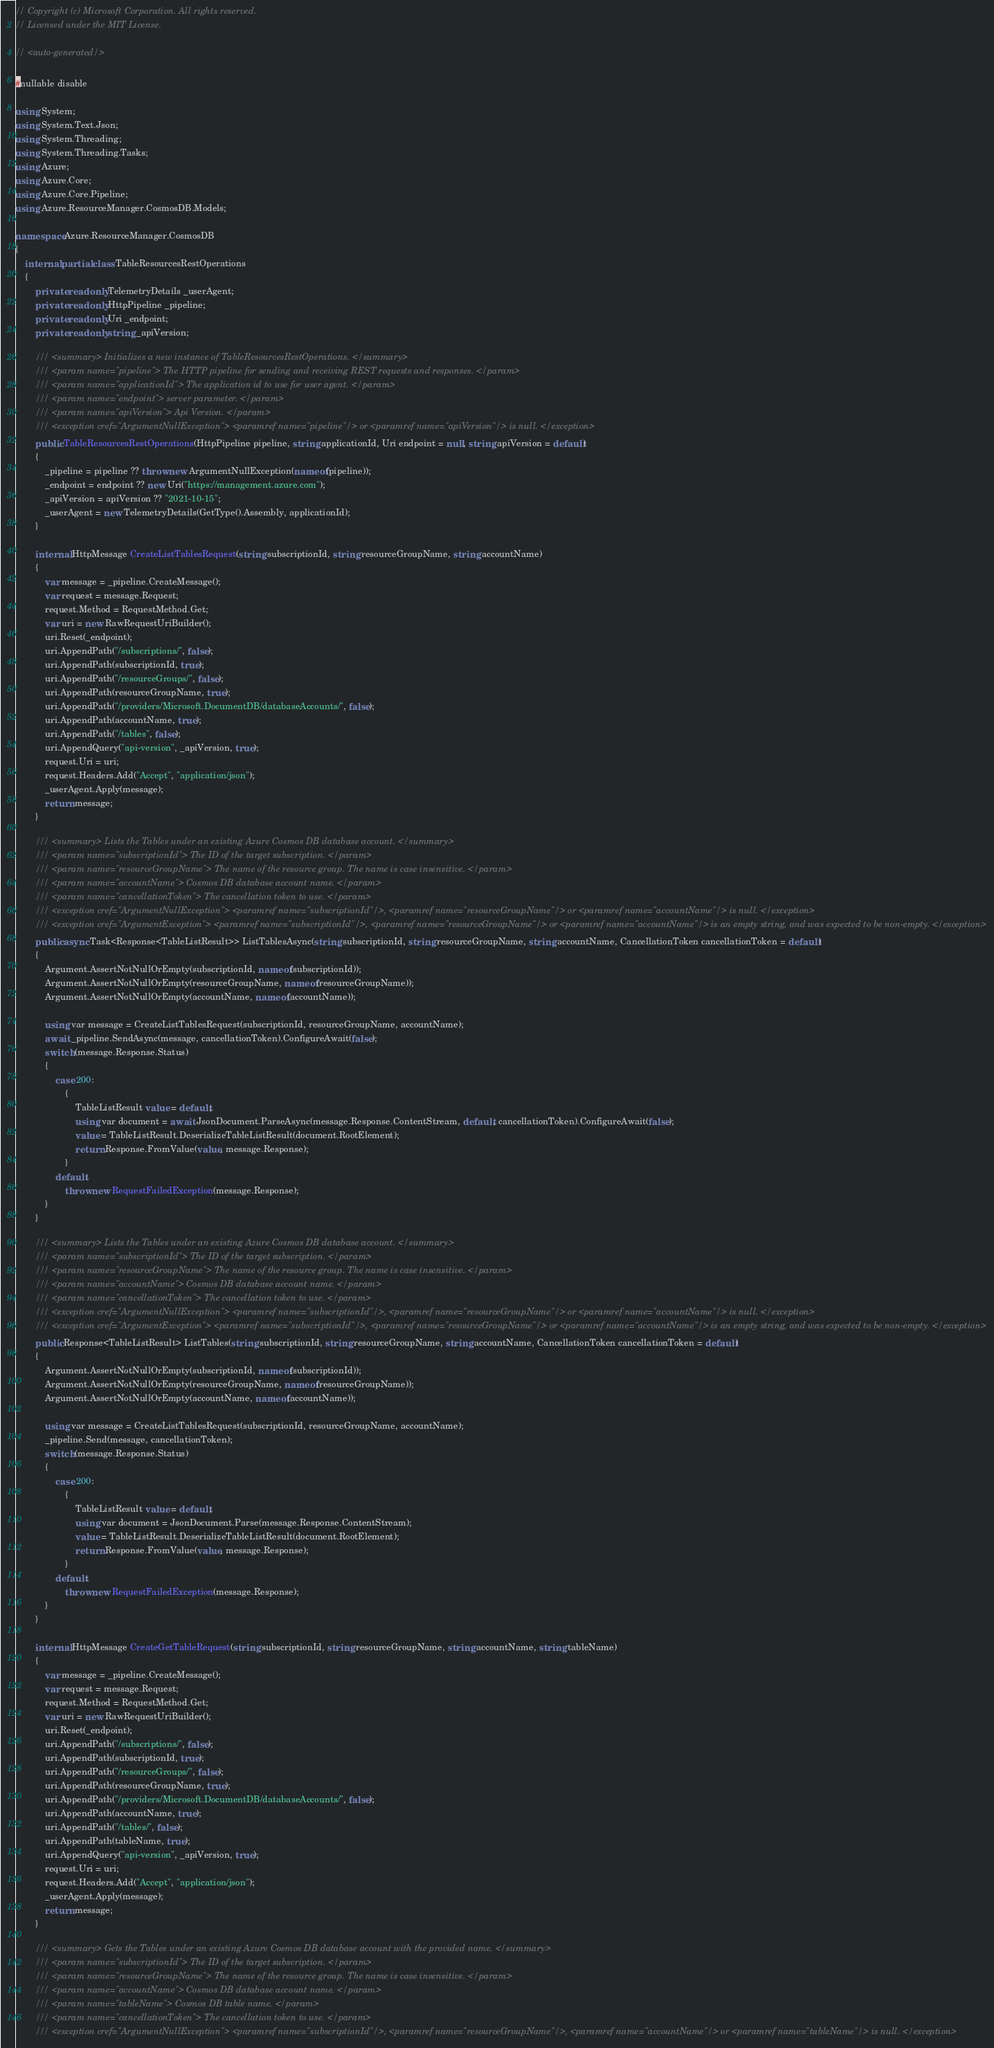<code> <loc_0><loc_0><loc_500><loc_500><_C#_>// Copyright (c) Microsoft Corporation. All rights reserved.
// Licensed under the MIT License.

// <auto-generated/>

#nullable disable

using System;
using System.Text.Json;
using System.Threading;
using System.Threading.Tasks;
using Azure;
using Azure.Core;
using Azure.Core.Pipeline;
using Azure.ResourceManager.CosmosDB.Models;

namespace Azure.ResourceManager.CosmosDB
{
    internal partial class TableResourcesRestOperations
    {
        private readonly TelemetryDetails _userAgent;
        private readonly HttpPipeline _pipeline;
        private readonly Uri _endpoint;
        private readonly string _apiVersion;

        /// <summary> Initializes a new instance of TableResourcesRestOperations. </summary>
        /// <param name="pipeline"> The HTTP pipeline for sending and receiving REST requests and responses. </param>
        /// <param name="applicationId"> The application id to use for user agent. </param>
        /// <param name="endpoint"> server parameter. </param>
        /// <param name="apiVersion"> Api Version. </param>
        /// <exception cref="ArgumentNullException"> <paramref name="pipeline"/> or <paramref name="apiVersion"/> is null. </exception>
        public TableResourcesRestOperations(HttpPipeline pipeline, string applicationId, Uri endpoint = null, string apiVersion = default)
        {
            _pipeline = pipeline ?? throw new ArgumentNullException(nameof(pipeline));
            _endpoint = endpoint ?? new Uri("https://management.azure.com");
            _apiVersion = apiVersion ?? "2021-10-15";
            _userAgent = new TelemetryDetails(GetType().Assembly, applicationId);
        }

        internal HttpMessage CreateListTablesRequest(string subscriptionId, string resourceGroupName, string accountName)
        {
            var message = _pipeline.CreateMessage();
            var request = message.Request;
            request.Method = RequestMethod.Get;
            var uri = new RawRequestUriBuilder();
            uri.Reset(_endpoint);
            uri.AppendPath("/subscriptions/", false);
            uri.AppendPath(subscriptionId, true);
            uri.AppendPath("/resourceGroups/", false);
            uri.AppendPath(resourceGroupName, true);
            uri.AppendPath("/providers/Microsoft.DocumentDB/databaseAccounts/", false);
            uri.AppendPath(accountName, true);
            uri.AppendPath("/tables", false);
            uri.AppendQuery("api-version", _apiVersion, true);
            request.Uri = uri;
            request.Headers.Add("Accept", "application/json");
            _userAgent.Apply(message);
            return message;
        }

        /// <summary> Lists the Tables under an existing Azure Cosmos DB database account. </summary>
        /// <param name="subscriptionId"> The ID of the target subscription. </param>
        /// <param name="resourceGroupName"> The name of the resource group. The name is case insensitive. </param>
        /// <param name="accountName"> Cosmos DB database account name. </param>
        /// <param name="cancellationToken"> The cancellation token to use. </param>
        /// <exception cref="ArgumentNullException"> <paramref name="subscriptionId"/>, <paramref name="resourceGroupName"/> or <paramref name="accountName"/> is null. </exception>
        /// <exception cref="ArgumentException"> <paramref name="subscriptionId"/>, <paramref name="resourceGroupName"/> or <paramref name="accountName"/> is an empty string, and was expected to be non-empty. </exception>
        public async Task<Response<TableListResult>> ListTablesAsync(string subscriptionId, string resourceGroupName, string accountName, CancellationToken cancellationToken = default)
        {
            Argument.AssertNotNullOrEmpty(subscriptionId, nameof(subscriptionId));
            Argument.AssertNotNullOrEmpty(resourceGroupName, nameof(resourceGroupName));
            Argument.AssertNotNullOrEmpty(accountName, nameof(accountName));

            using var message = CreateListTablesRequest(subscriptionId, resourceGroupName, accountName);
            await _pipeline.SendAsync(message, cancellationToken).ConfigureAwait(false);
            switch (message.Response.Status)
            {
                case 200:
                    {
                        TableListResult value = default;
                        using var document = await JsonDocument.ParseAsync(message.Response.ContentStream, default, cancellationToken).ConfigureAwait(false);
                        value = TableListResult.DeserializeTableListResult(document.RootElement);
                        return Response.FromValue(value, message.Response);
                    }
                default:
                    throw new RequestFailedException(message.Response);
            }
        }

        /// <summary> Lists the Tables under an existing Azure Cosmos DB database account. </summary>
        /// <param name="subscriptionId"> The ID of the target subscription. </param>
        /// <param name="resourceGroupName"> The name of the resource group. The name is case insensitive. </param>
        /// <param name="accountName"> Cosmos DB database account name. </param>
        /// <param name="cancellationToken"> The cancellation token to use. </param>
        /// <exception cref="ArgumentNullException"> <paramref name="subscriptionId"/>, <paramref name="resourceGroupName"/> or <paramref name="accountName"/> is null. </exception>
        /// <exception cref="ArgumentException"> <paramref name="subscriptionId"/>, <paramref name="resourceGroupName"/> or <paramref name="accountName"/> is an empty string, and was expected to be non-empty. </exception>
        public Response<TableListResult> ListTables(string subscriptionId, string resourceGroupName, string accountName, CancellationToken cancellationToken = default)
        {
            Argument.AssertNotNullOrEmpty(subscriptionId, nameof(subscriptionId));
            Argument.AssertNotNullOrEmpty(resourceGroupName, nameof(resourceGroupName));
            Argument.AssertNotNullOrEmpty(accountName, nameof(accountName));

            using var message = CreateListTablesRequest(subscriptionId, resourceGroupName, accountName);
            _pipeline.Send(message, cancellationToken);
            switch (message.Response.Status)
            {
                case 200:
                    {
                        TableListResult value = default;
                        using var document = JsonDocument.Parse(message.Response.ContentStream);
                        value = TableListResult.DeserializeTableListResult(document.RootElement);
                        return Response.FromValue(value, message.Response);
                    }
                default:
                    throw new RequestFailedException(message.Response);
            }
        }

        internal HttpMessage CreateGetTableRequest(string subscriptionId, string resourceGroupName, string accountName, string tableName)
        {
            var message = _pipeline.CreateMessage();
            var request = message.Request;
            request.Method = RequestMethod.Get;
            var uri = new RawRequestUriBuilder();
            uri.Reset(_endpoint);
            uri.AppendPath("/subscriptions/", false);
            uri.AppendPath(subscriptionId, true);
            uri.AppendPath("/resourceGroups/", false);
            uri.AppendPath(resourceGroupName, true);
            uri.AppendPath("/providers/Microsoft.DocumentDB/databaseAccounts/", false);
            uri.AppendPath(accountName, true);
            uri.AppendPath("/tables/", false);
            uri.AppendPath(tableName, true);
            uri.AppendQuery("api-version", _apiVersion, true);
            request.Uri = uri;
            request.Headers.Add("Accept", "application/json");
            _userAgent.Apply(message);
            return message;
        }

        /// <summary> Gets the Tables under an existing Azure Cosmos DB database account with the provided name. </summary>
        /// <param name="subscriptionId"> The ID of the target subscription. </param>
        /// <param name="resourceGroupName"> The name of the resource group. The name is case insensitive. </param>
        /// <param name="accountName"> Cosmos DB database account name. </param>
        /// <param name="tableName"> Cosmos DB table name. </param>
        /// <param name="cancellationToken"> The cancellation token to use. </param>
        /// <exception cref="ArgumentNullException"> <paramref name="subscriptionId"/>, <paramref name="resourceGroupName"/>, <paramref name="accountName"/> or <paramref name="tableName"/> is null. </exception></code> 